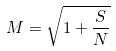Convert formula to latex. <formula><loc_0><loc_0><loc_500><loc_500>M = \sqrt { 1 + \frac { S } { N } }</formula> 